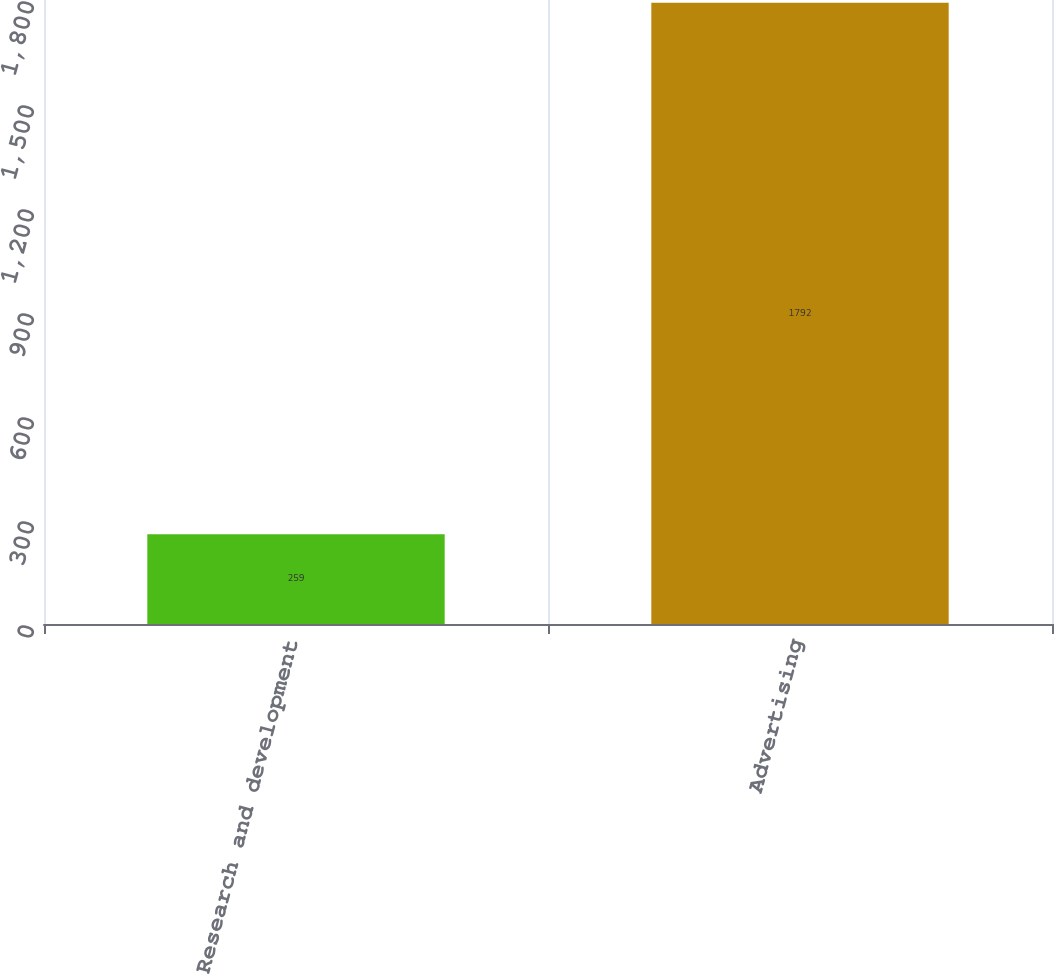Convert chart. <chart><loc_0><loc_0><loc_500><loc_500><bar_chart><fcel>Research and development<fcel>Advertising<nl><fcel>259<fcel>1792<nl></chart> 